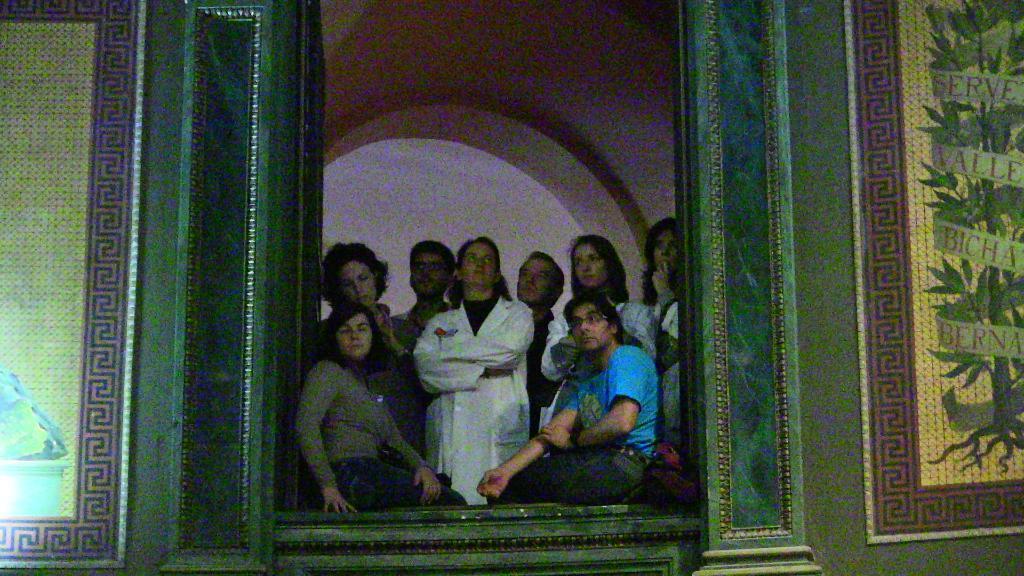Describe this image in one or two sentences. In this picture we can see a man and a woman sitting. Behind them we can see people are standing. This picture is blur. 